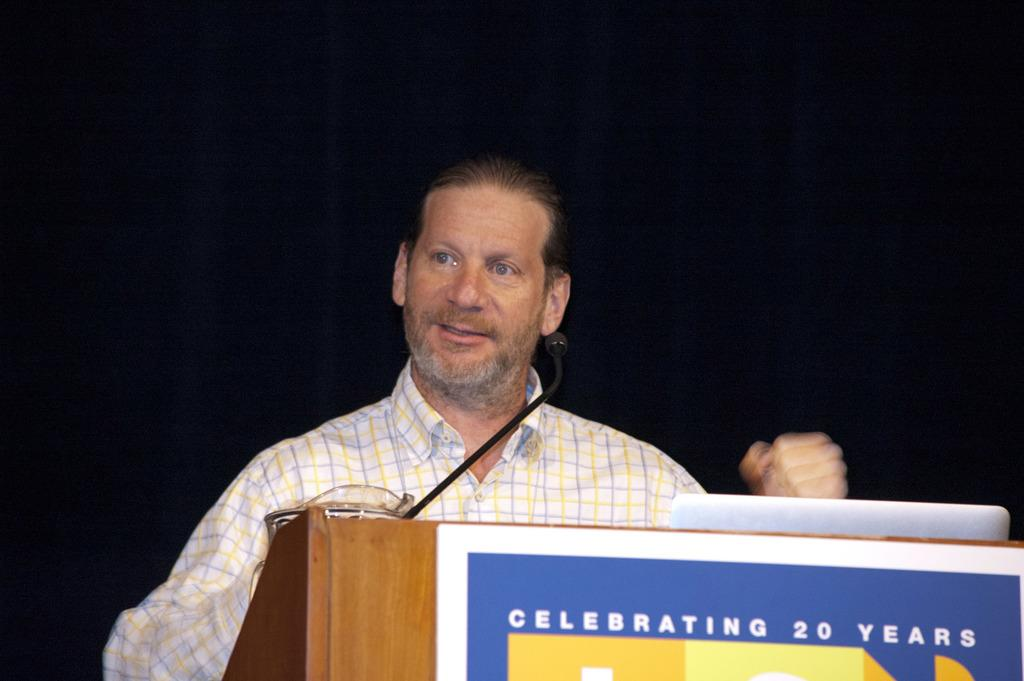What is located in the foreground of the image? There is a poster and a podium in the foreground of the image. What is the man in the image doing? The man is standing in front of the podium. What equipment is present on the podium? There is a microphone and a laptop on the podium. What can be observed about the background of the image? The background of the image is dark. How many stations are visible in the image? There are no stations present in the image. What color are the man's eyes in the image? The man's eyes are not visible in the image, so we cannot determine their color. 